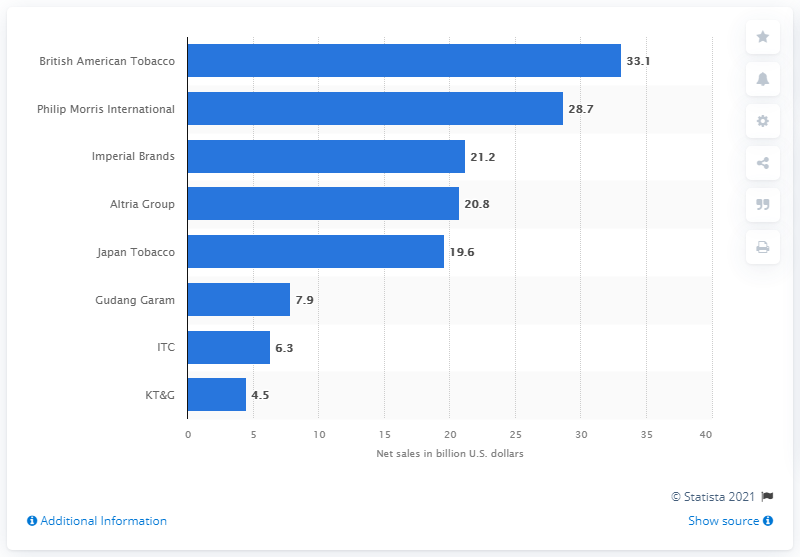Give some essential details in this illustration. British American Tobacco was the leading tobacco company worldwide in 2020. The total net sales of British American Tobacco and Phillip Morris International were 61.8 billion U.S. dollars. Philip Morris International was the second largest tobacco company in the world in 2020. British American Tobacco was the tobacco company that produced Camel, Lucky Strike, and Newport cigarettes. 